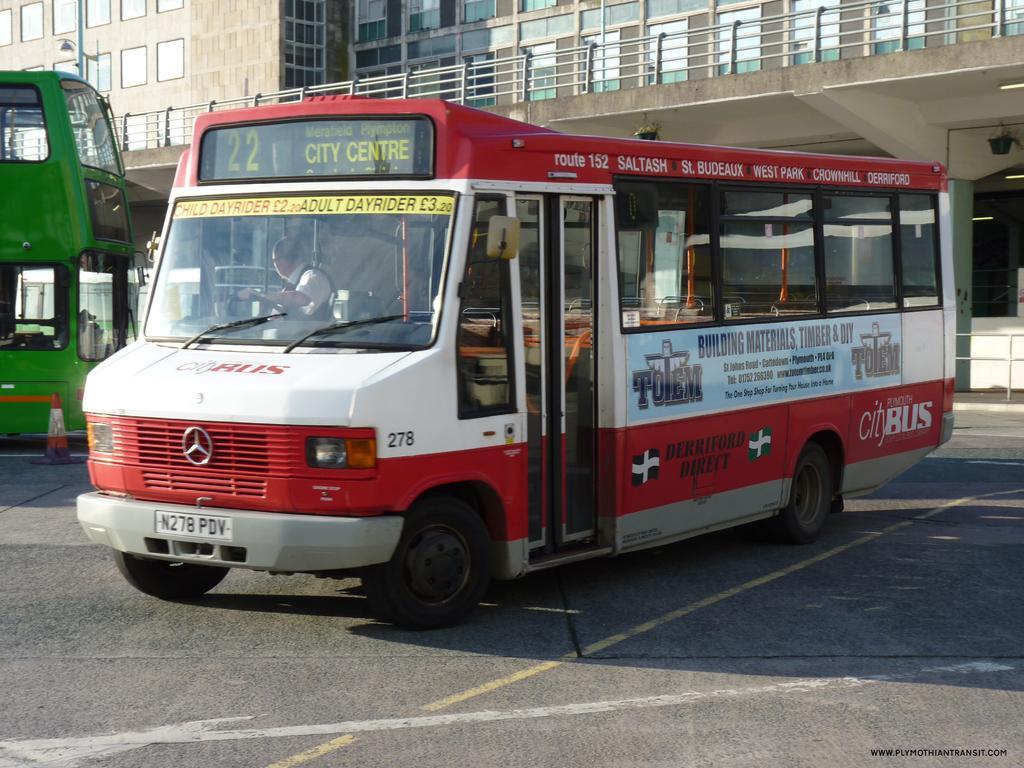In one or two sentences, can you explain what this image depicts? In this picture I can see a building and couple of buses. 